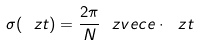<formula> <loc_0><loc_0><loc_500><loc_500>\sigma ( \ z t ) = \frac { 2 \pi } { N } \ z v e c { e } \cdot \ z t</formula> 